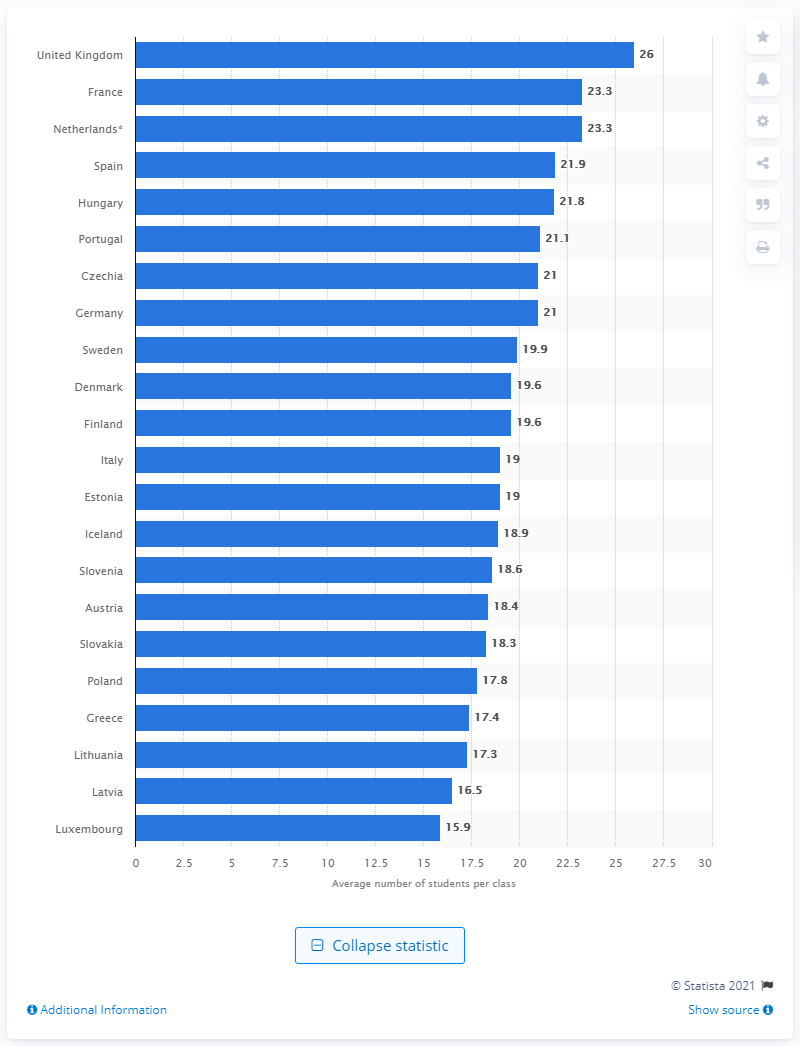Identify some key points in this picture. In 2018, Luxembourg had an average of 15.9 students per class. 